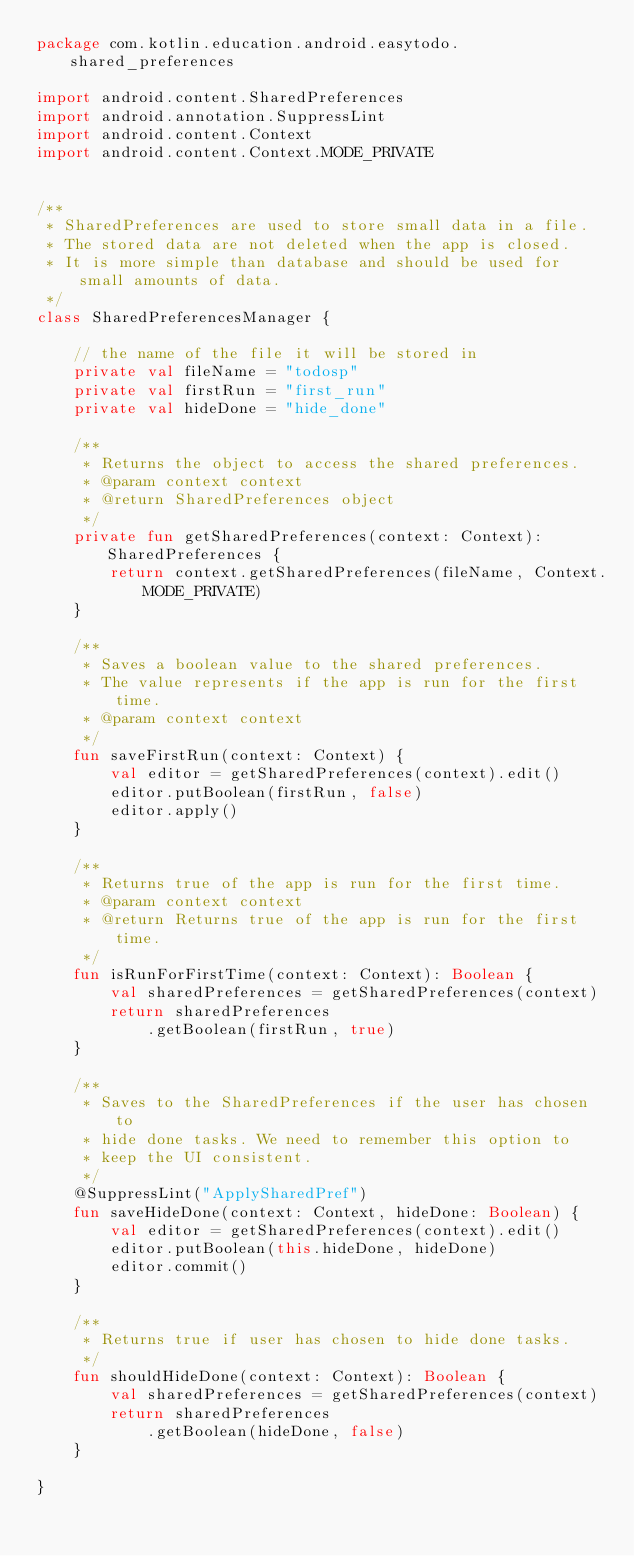<code> <loc_0><loc_0><loc_500><loc_500><_Kotlin_>package com.kotlin.education.android.easytodo.shared_preferences

import android.content.SharedPreferences
import android.annotation.SuppressLint
import android.content.Context
import android.content.Context.MODE_PRIVATE


/**
 * SharedPreferences are used to store small data in a file.
 * The stored data are not deleted when the app is closed.
 * It is more simple than database and should be used for small amounts of data.
 */
class SharedPreferencesManager {

    // the name of the file it will be stored in
    private val fileName = "todosp"
    private val firstRun = "first_run"
    private val hideDone = "hide_done"

    /**
     * Returns the object to access the shared preferences.
     * @param context context
     * @return SharedPreferences object
     */
    private fun getSharedPreferences(context: Context): SharedPreferences {
        return context.getSharedPreferences(fileName, Context.MODE_PRIVATE)
    }

    /**
     * Saves a boolean value to the shared preferences.
     * The value represents if the app is run for the first time.
     * @param context context
     */
    fun saveFirstRun(context: Context) {
        val editor = getSharedPreferences(context).edit()
        editor.putBoolean(firstRun, false)
        editor.apply()
    }

    /**
     * Returns true of the app is run for the first time.
     * @param context context
     * @return Returns true of the app is run for the first time.
     */
    fun isRunForFirstTime(context: Context): Boolean {
        val sharedPreferences = getSharedPreferences(context)
        return sharedPreferences
            .getBoolean(firstRun, true)
    }

    /**
     * Saves to the SharedPreferences if the user has chosen to
     * hide done tasks. We need to remember this option to
     * keep the UI consistent.
     */
    @SuppressLint("ApplySharedPref")
    fun saveHideDone(context: Context, hideDone: Boolean) {
        val editor = getSharedPreferences(context).edit()
        editor.putBoolean(this.hideDone, hideDone)
        editor.commit()
    }

    /**
     * Returns true if user has chosen to hide done tasks.
     */
    fun shouldHideDone(context: Context): Boolean {
        val sharedPreferences = getSharedPreferences(context)
        return sharedPreferences
            .getBoolean(hideDone, false)
    }

}</code> 